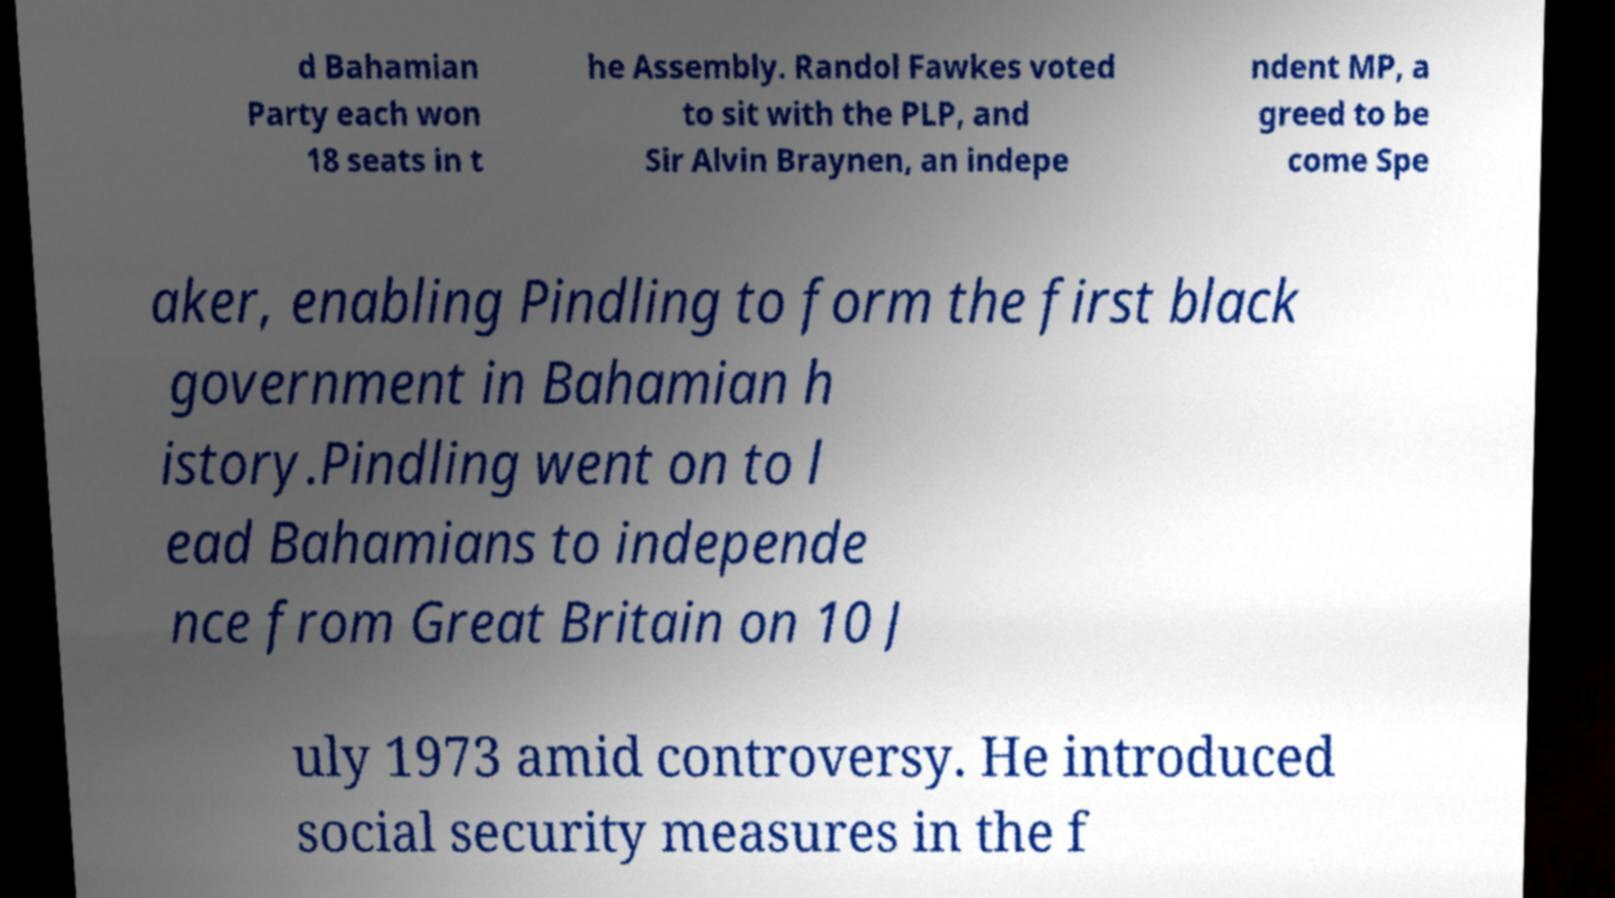Can you read and provide the text displayed in the image?This photo seems to have some interesting text. Can you extract and type it out for me? d Bahamian Party each won 18 seats in t he Assembly. Randol Fawkes voted to sit with the PLP, and Sir Alvin Braynen, an indepe ndent MP, a greed to be come Spe aker, enabling Pindling to form the first black government in Bahamian h istory.Pindling went on to l ead Bahamians to independe nce from Great Britain on 10 J uly 1973 amid controversy. He introduced social security measures in the f 